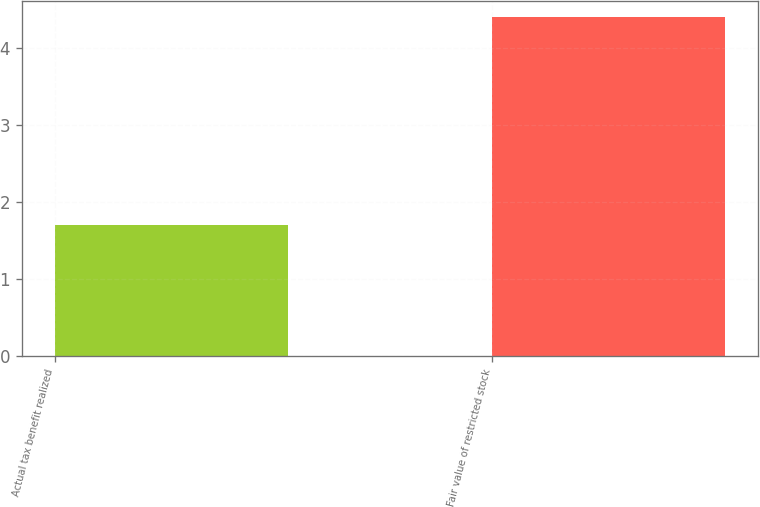Convert chart to OTSL. <chart><loc_0><loc_0><loc_500><loc_500><bar_chart><fcel>Actual tax benefit realized<fcel>Fair value of restricted stock<nl><fcel>1.7<fcel>4.4<nl></chart> 